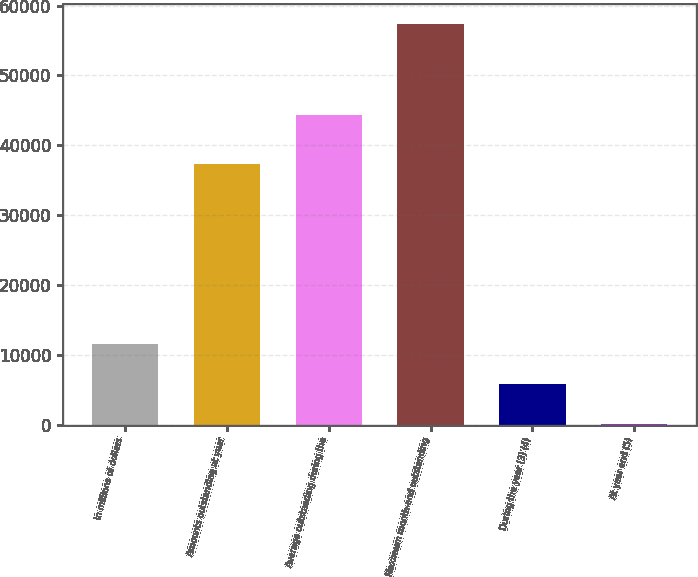Convert chart to OTSL. <chart><loc_0><loc_0><loc_500><loc_500><bar_chart><fcel>In millions of dollars<fcel>Amounts outstanding at year<fcel>Average outstanding during the<fcel>Maximum month-end outstanding<fcel>During the year (3) (4)<fcel>At year end (5)<nl><fcel>11464.5<fcel>37343<fcel>44274<fcel>57303<fcel>5734.73<fcel>4.92<nl></chart> 